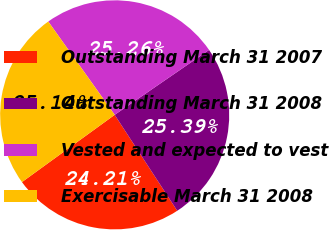Convert chart to OTSL. <chart><loc_0><loc_0><loc_500><loc_500><pie_chart><fcel>Outstanding March 31 2007<fcel>Outstanding March 31 2008<fcel>Vested and expected to vest<fcel>Exercisable March 31 2008<nl><fcel>24.21%<fcel>25.39%<fcel>25.26%<fcel>25.14%<nl></chart> 